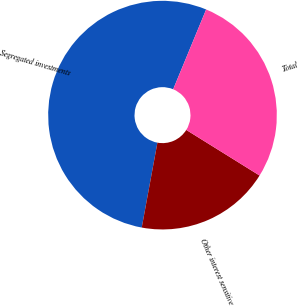Convert chart. <chart><loc_0><loc_0><loc_500><loc_500><pie_chart><fcel>Segregated investments<fcel>Other interest sensitive<fcel>Total<nl><fcel>53.33%<fcel>19.05%<fcel>27.62%<nl></chart> 